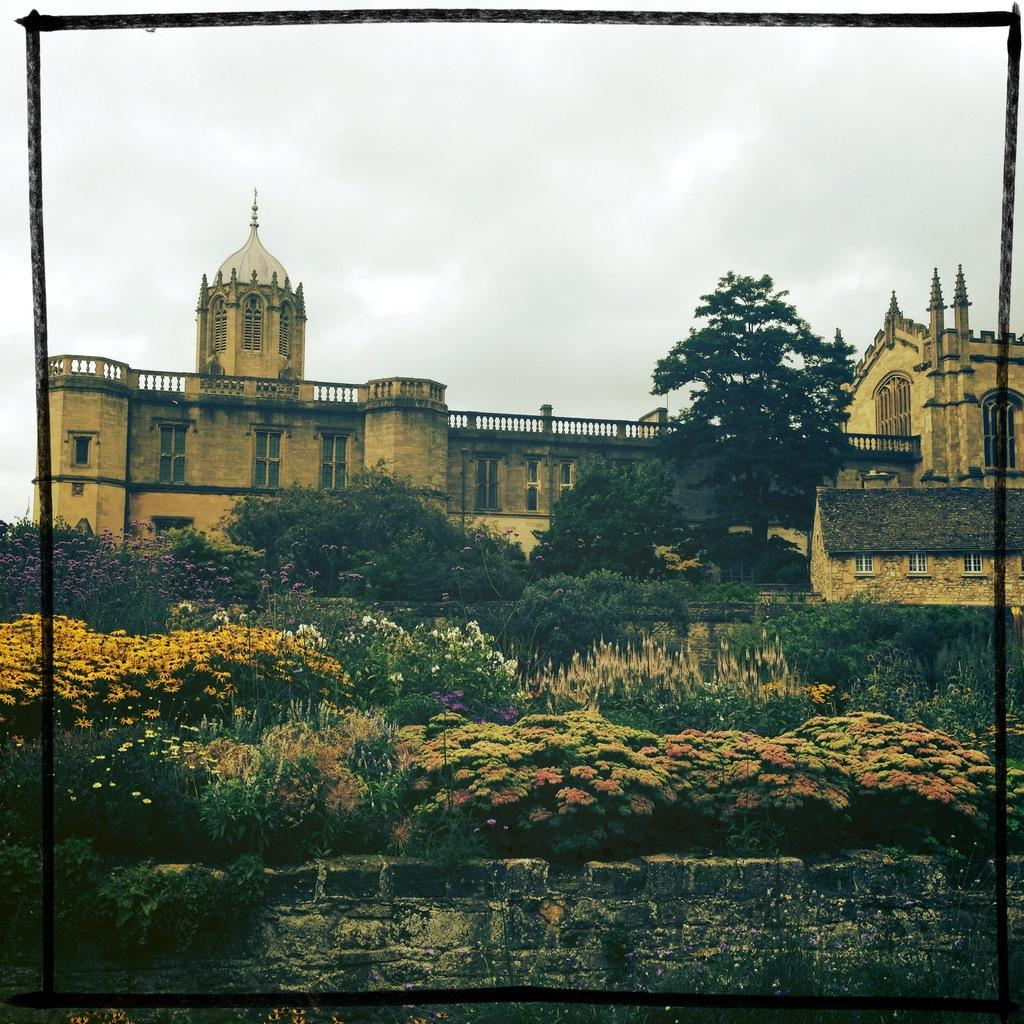What type of structures can be seen in the image? There are buildings in the image. What type of vegetation is present in the image? There are trees and flowers in the image. What type of cloth is draped over the bed in the image? There is no bed or cloth present in the image; it features buildings, trees, and flowers. What type of fruit is hanging from the trees in the image? There is no fruit visible in the image; only trees and flowers are present. 